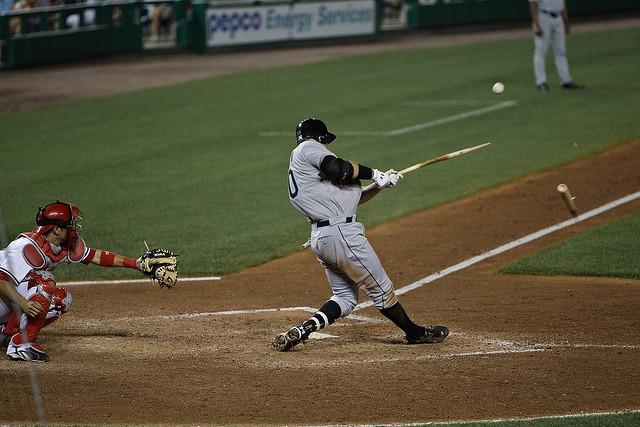Is the batter in the correct spot?
Short answer required. Yes. What happened the hitter's bat?
Short answer required. Broke. How fast was the ball coming?
Keep it brief. Very fast. Is the photo in focus?
Give a very brief answer. Yes. 